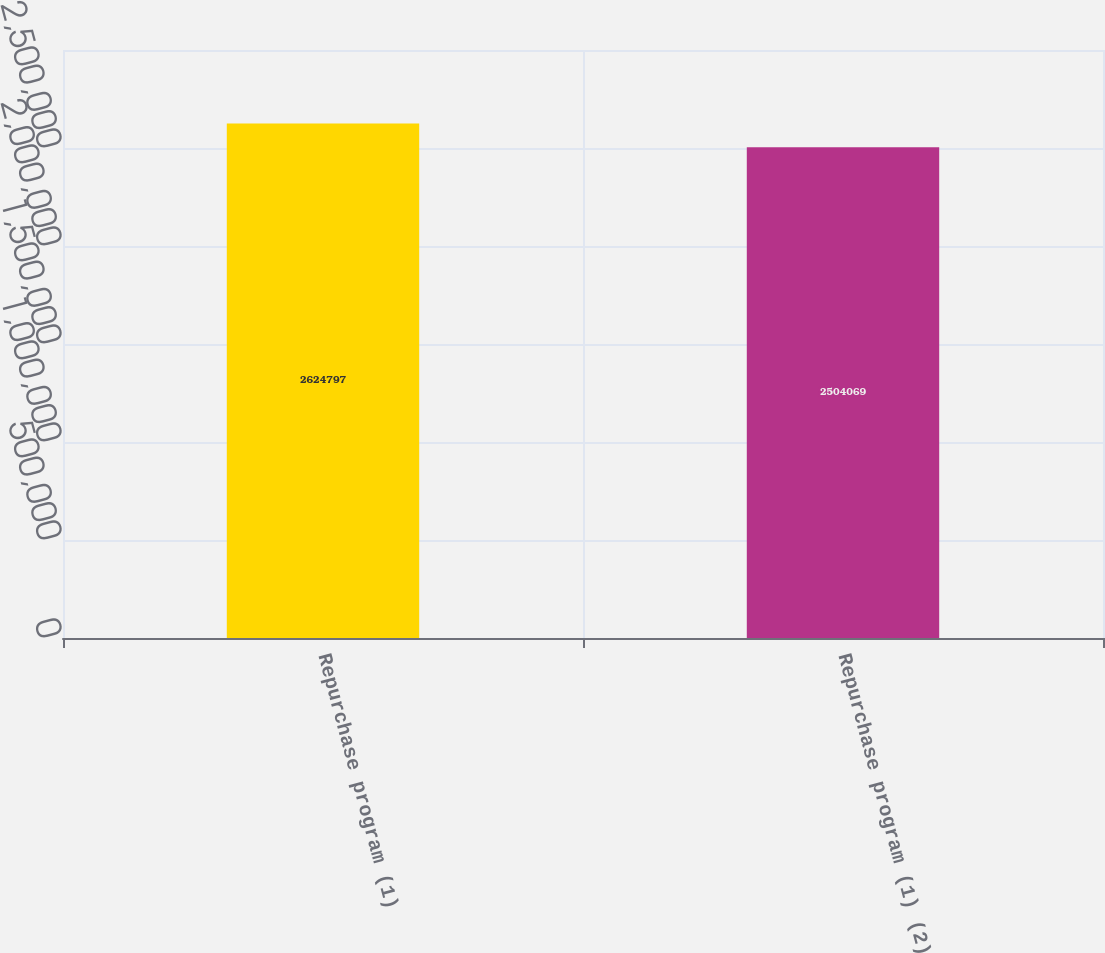<chart> <loc_0><loc_0><loc_500><loc_500><bar_chart><fcel>Repurchase program (1)<fcel>Repurchase program (1) (2)<nl><fcel>2.6248e+06<fcel>2.50407e+06<nl></chart> 